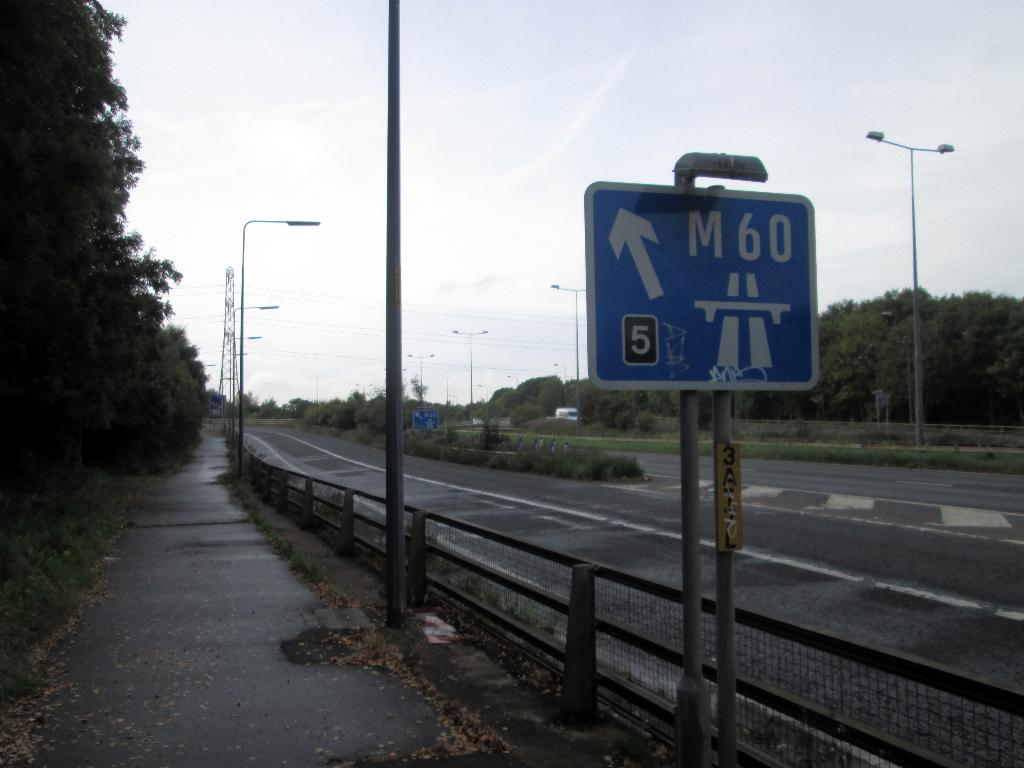<image>
Summarize the visual content of the image. A view of a highway with a sign pointing to the M60 exit in 5 kilometers. 